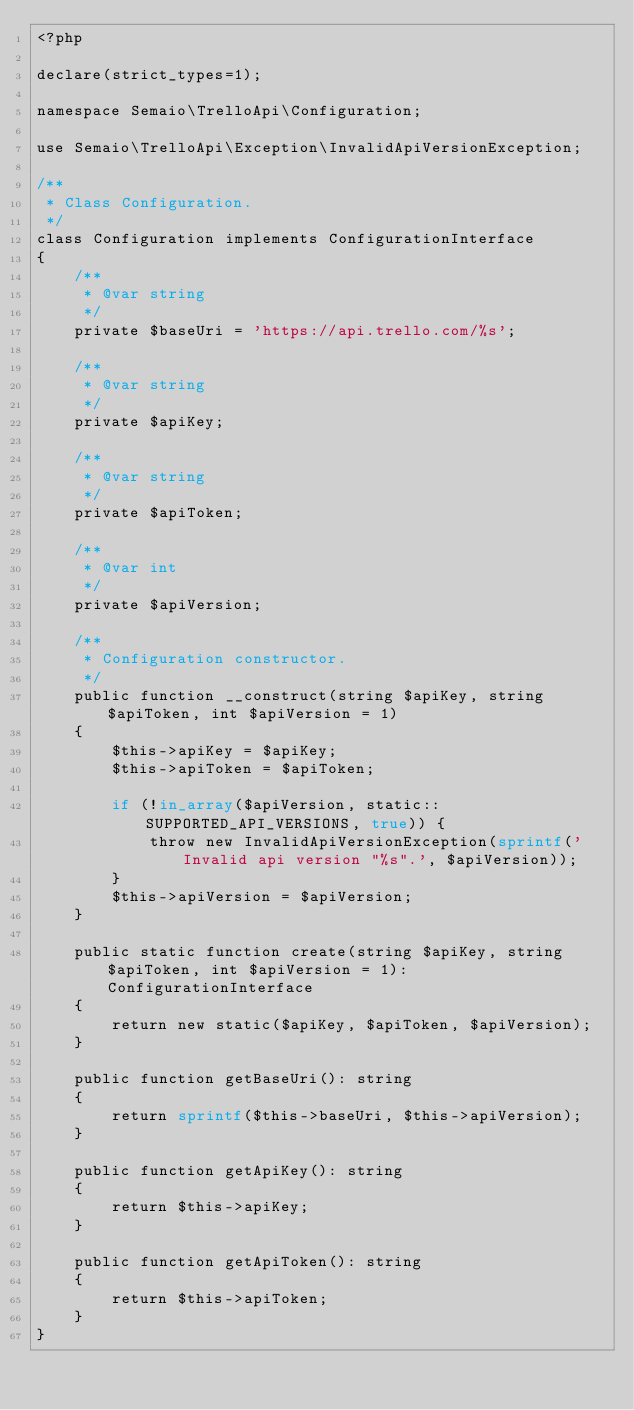Convert code to text. <code><loc_0><loc_0><loc_500><loc_500><_PHP_><?php

declare(strict_types=1);

namespace Semaio\TrelloApi\Configuration;

use Semaio\TrelloApi\Exception\InvalidApiVersionException;

/**
 * Class Configuration.
 */
class Configuration implements ConfigurationInterface
{
    /**
     * @var string
     */
    private $baseUri = 'https://api.trello.com/%s';

    /**
     * @var string
     */
    private $apiKey;

    /**
     * @var string
     */
    private $apiToken;

    /**
     * @var int
     */
    private $apiVersion;

    /**
     * Configuration constructor.
     */
    public function __construct(string $apiKey, string $apiToken, int $apiVersion = 1)
    {
        $this->apiKey = $apiKey;
        $this->apiToken = $apiToken;

        if (!in_array($apiVersion, static::SUPPORTED_API_VERSIONS, true)) {
            throw new InvalidApiVersionException(sprintf('Invalid api version "%s".', $apiVersion));
        }
        $this->apiVersion = $apiVersion;
    }

    public static function create(string $apiKey, string $apiToken, int $apiVersion = 1): ConfigurationInterface
    {
        return new static($apiKey, $apiToken, $apiVersion);
    }

    public function getBaseUri(): string
    {
        return sprintf($this->baseUri, $this->apiVersion);
    }

    public function getApiKey(): string
    {
        return $this->apiKey;
    }

    public function getApiToken(): string
    {
        return $this->apiToken;
    }
}
</code> 